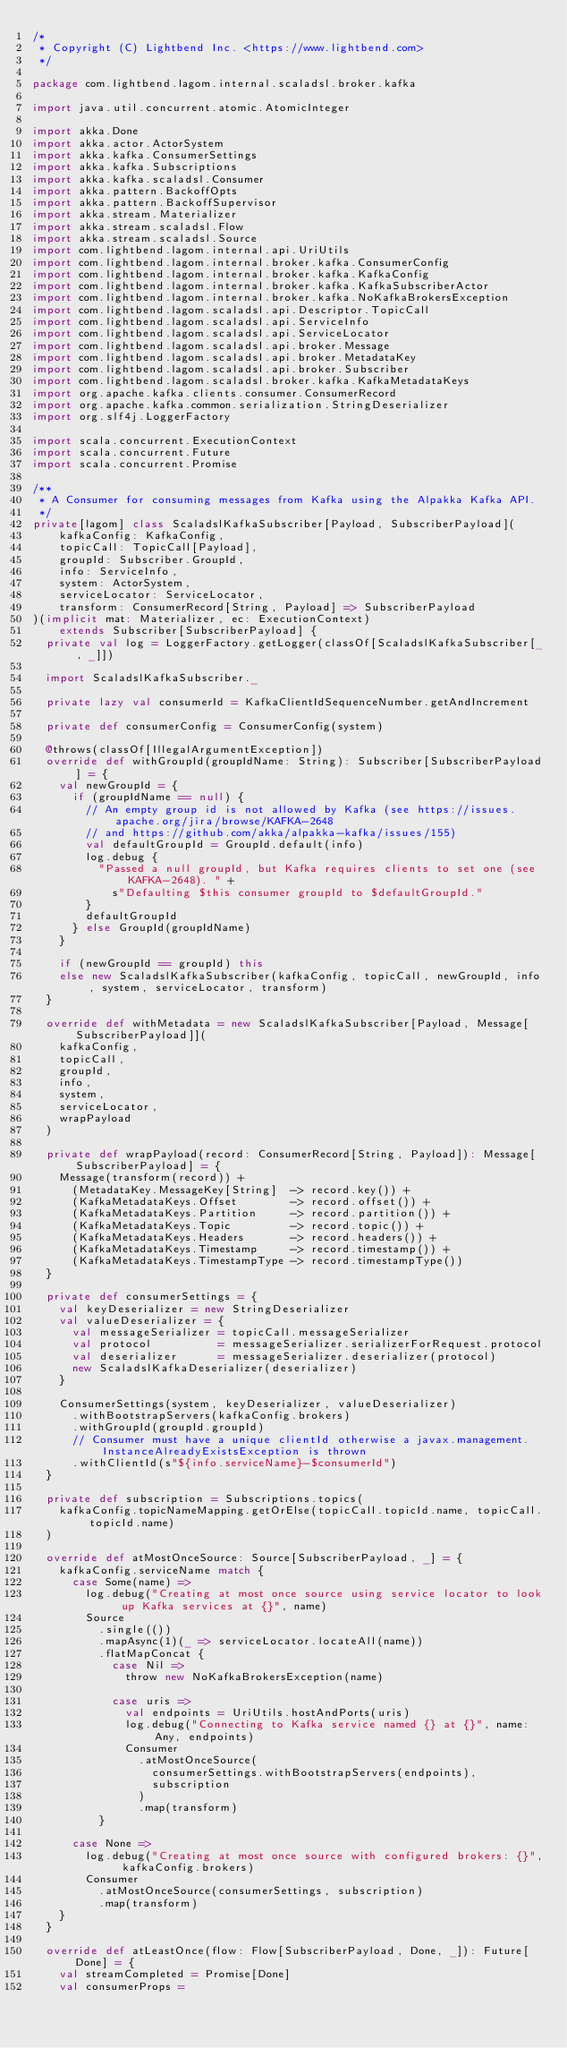<code> <loc_0><loc_0><loc_500><loc_500><_Scala_>/*
 * Copyright (C) Lightbend Inc. <https://www.lightbend.com>
 */

package com.lightbend.lagom.internal.scaladsl.broker.kafka

import java.util.concurrent.atomic.AtomicInteger

import akka.Done
import akka.actor.ActorSystem
import akka.kafka.ConsumerSettings
import akka.kafka.Subscriptions
import akka.kafka.scaladsl.Consumer
import akka.pattern.BackoffOpts
import akka.pattern.BackoffSupervisor
import akka.stream.Materializer
import akka.stream.scaladsl.Flow
import akka.stream.scaladsl.Source
import com.lightbend.lagom.internal.api.UriUtils
import com.lightbend.lagom.internal.broker.kafka.ConsumerConfig
import com.lightbend.lagom.internal.broker.kafka.KafkaConfig
import com.lightbend.lagom.internal.broker.kafka.KafkaSubscriberActor
import com.lightbend.lagom.internal.broker.kafka.NoKafkaBrokersException
import com.lightbend.lagom.scaladsl.api.Descriptor.TopicCall
import com.lightbend.lagom.scaladsl.api.ServiceInfo
import com.lightbend.lagom.scaladsl.api.ServiceLocator
import com.lightbend.lagom.scaladsl.api.broker.Message
import com.lightbend.lagom.scaladsl.api.broker.MetadataKey
import com.lightbend.lagom.scaladsl.api.broker.Subscriber
import com.lightbend.lagom.scaladsl.broker.kafka.KafkaMetadataKeys
import org.apache.kafka.clients.consumer.ConsumerRecord
import org.apache.kafka.common.serialization.StringDeserializer
import org.slf4j.LoggerFactory

import scala.concurrent.ExecutionContext
import scala.concurrent.Future
import scala.concurrent.Promise

/**
 * A Consumer for consuming messages from Kafka using the Alpakka Kafka API.
 */
private[lagom] class ScaladslKafkaSubscriber[Payload, SubscriberPayload](
    kafkaConfig: KafkaConfig,
    topicCall: TopicCall[Payload],
    groupId: Subscriber.GroupId,
    info: ServiceInfo,
    system: ActorSystem,
    serviceLocator: ServiceLocator,
    transform: ConsumerRecord[String, Payload] => SubscriberPayload
)(implicit mat: Materializer, ec: ExecutionContext)
    extends Subscriber[SubscriberPayload] {
  private val log = LoggerFactory.getLogger(classOf[ScaladslKafkaSubscriber[_, _]])

  import ScaladslKafkaSubscriber._

  private lazy val consumerId = KafkaClientIdSequenceNumber.getAndIncrement

  private def consumerConfig = ConsumerConfig(system)

  @throws(classOf[IllegalArgumentException])
  override def withGroupId(groupIdName: String): Subscriber[SubscriberPayload] = {
    val newGroupId = {
      if (groupIdName == null) {
        // An empty group id is not allowed by Kafka (see https://issues.apache.org/jira/browse/KAFKA-2648
        // and https://github.com/akka/alpakka-kafka/issues/155)
        val defaultGroupId = GroupId.default(info)
        log.debug {
          "Passed a null groupId, but Kafka requires clients to set one (see KAFKA-2648). " +
            s"Defaulting $this consumer groupId to $defaultGroupId."
        }
        defaultGroupId
      } else GroupId(groupIdName)
    }

    if (newGroupId == groupId) this
    else new ScaladslKafkaSubscriber(kafkaConfig, topicCall, newGroupId, info, system, serviceLocator, transform)
  }

  override def withMetadata = new ScaladslKafkaSubscriber[Payload, Message[SubscriberPayload]](
    kafkaConfig,
    topicCall,
    groupId,
    info,
    system,
    serviceLocator,
    wrapPayload
  )

  private def wrapPayload(record: ConsumerRecord[String, Payload]): Message[SubscriberPayload] = {
    Message(transform(record)) +
      (MetadataKey.MessageKey[String]  -> record.key()) +
      (KafkaMetadataKeys.Offset        -> record.offset()) +
      (KafkaMetadataKeys.Partition     -> record.partition()) +
      (KafkaMetadataKeys.Topic         -> record.topic()) +
      (KafkaMetadataKeys.Headers       -> record.headers()) +
      (KafkaMetadataKeys.Timestamp     -> record.timestamp()) +
      (KafkaMetadataKeys.TimestampType -> record.timestampType())
  }

  private def consumerSettings = {
    val keyDeserializer = new StringDeserializer
    val valueDeserializer = {
      val messageSerializer = topicCall.messageSerializer
      val protocol          = messageSerializer.serializerForRequest.protocol
      val deserializer      = messageSerializer.deserializer(protocol)
      new ScaladslKafkaDeserializer(deserializer)
    }

    ConsumerSettings(system, keyDeserializer, valueDeserializer)
      .withBootstrapServers(kafkaConfig.brokers)
      .withGroupId(groupId.groupId)
      // Consumer must have a unique clientId otherwise a javax.management.InstanceAlreadyExistsException is thrown
      .withClientId(s"${info.serviceName}-$consumerId")
  }

  private def subscription = Subscriptions.topics(
    kafkaConfig.topicNameMapping.getOrElse(topicCall.topicId.name, topicCall.topicId.name)
  )

  override def atMostOnceSource: Source[SubscriberPayload, _] = {
    kafkaConfig.serviceName match {
      case Some(name) =>
        log.debug("Creating at most once source using service locator to look up Kafka services at {}", name)
        Source
          .single(())
          .mapAsync(1)(_ => serviceLocator.locateAll(name))
          .flatMapConcat {
            case Nil =>
              throw new NoKafkaBrokersException(name)

            case uris =>
              val endpoints = UriUtils.hostAndPorts(uris)
              log.debug("Connecting to Kafka service named {} at {}", name: Any, endpoints)
              Consumer
                .atMostOnceSource(
                  consumerSettings.withBootstrapServers(endpoints),
                  subscription
                )
                .map(transform)
          }

      case None =>
        log.debug("Creating at most once source with configured brokers: {}", kafkaConfig.brokers)
        Consumer
          .atMostOnceSource(consumerSettings, subscription)
          .map(transform)
    }
  }

  override def atLeastOnce(flow: Flow[SubscriberPayload, Done, _]): Future[Done] = {
    val streamCompleted = Promise[Done]
    val consumerProps =</code> 